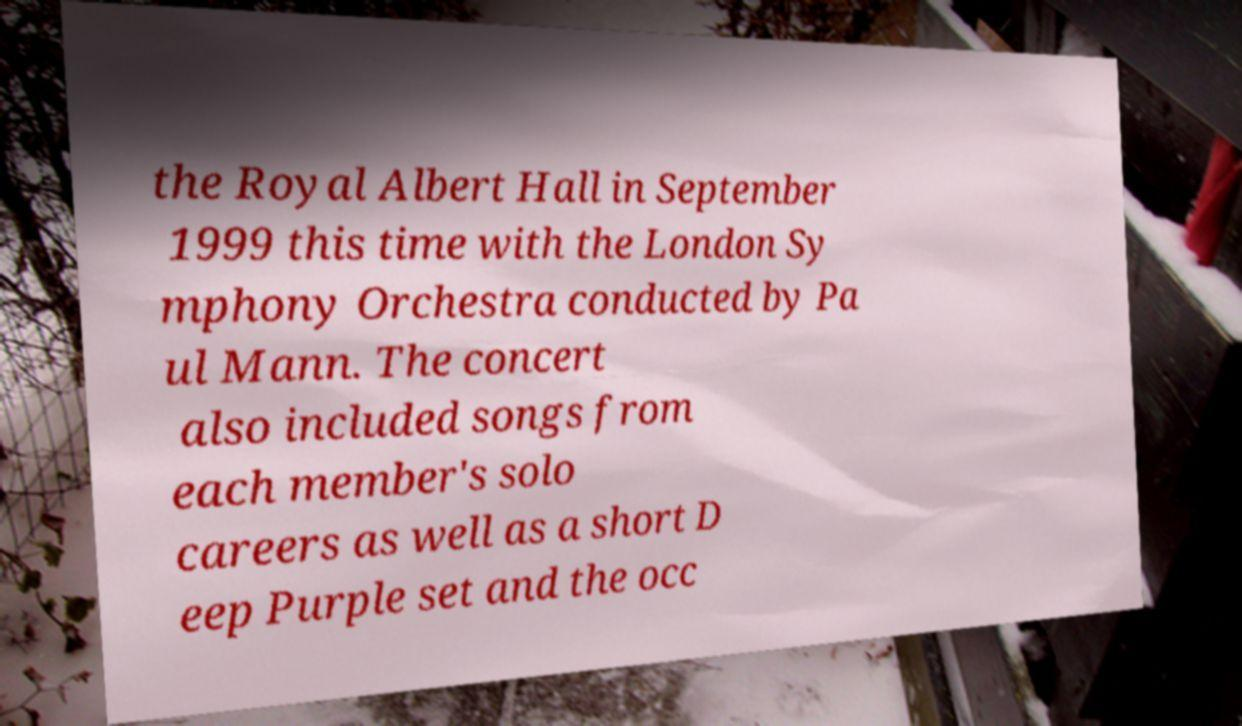Could you extract and type out the text from this image? the Royal Albert Hall in September 1999 this time with the London Sy mphony Orchestra conducted by Pa ul Mann. The concert also included songs from each member's solo careers as well as a short D eep Purple set and the occ 